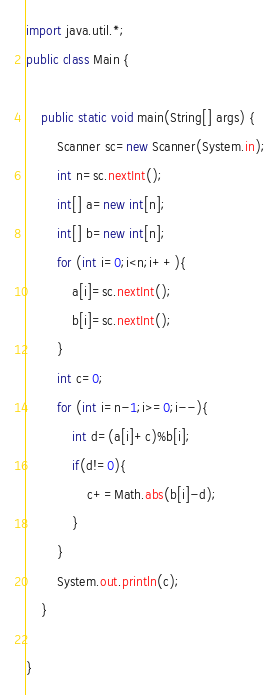<code> <loc_0><loc_0><loc_500><loc_500><_Java_>import java.util.*;
public class Main {

	public static void main(String[] args) {
		Scanner sc=new Scanner(System.in);
		int n=sc.nextInt();
		int[] a=new int[n];
		int[] b=new int[n];
		for (int i=0;i<n;i++){
			a[i]=sc.nextInt();
			b[i]=sc.nextInt();
		}
		int c=0;
		for (int i=n-1;i>=0;i--){
			int d=(a[i]+c)%b[i];
			if(d!=0){
				c+=Math.abs(b[i]-d);
			}
		}
		System.out.println(c);
	}

}</code> 